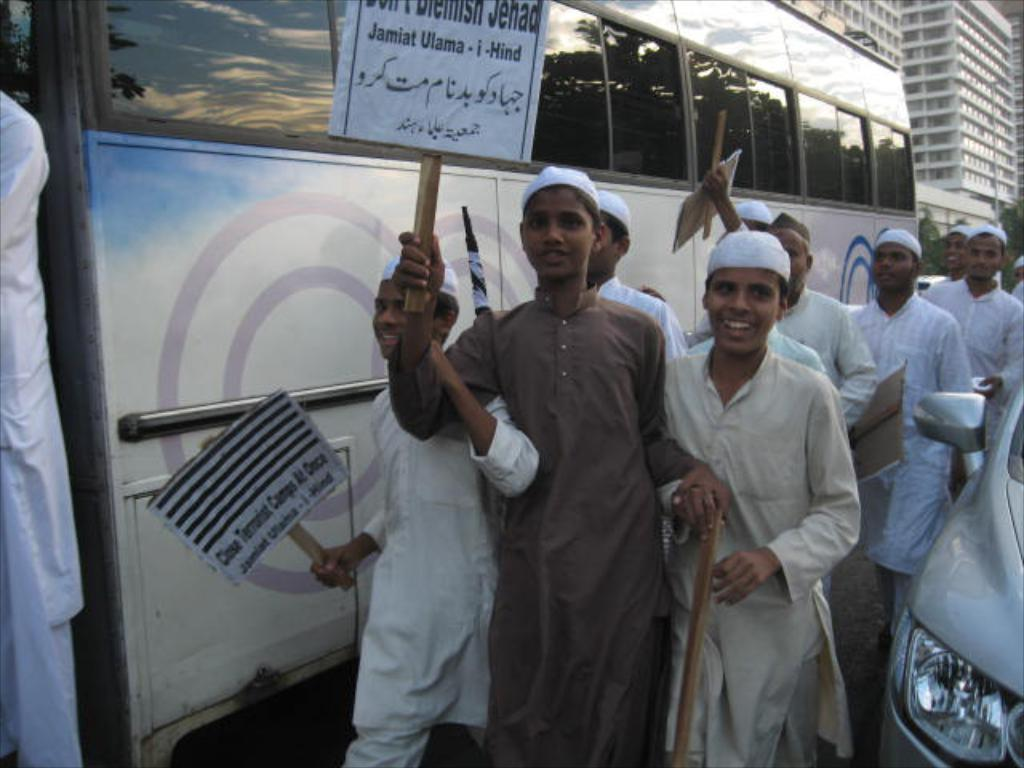What are the people in the image doing? The people in the image are walking. Where are the people walking? The people are walking along a road. What else can be seen on the road? There are vehicles on the road. What are the people carrying? The people are carrying boards. What can be seen in the background of the image? There are buildings visible in the image. What type of cover is protecting the ducks in the image? There are no ducks present in the image, so there is no cover for them. 